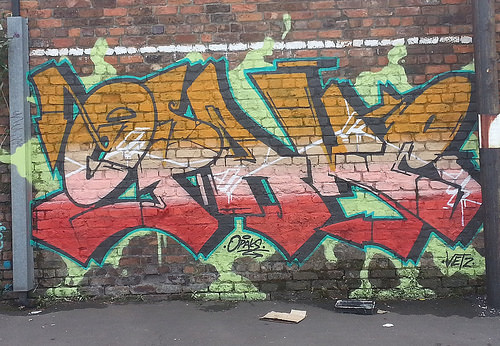<image>
Can you confirm if the graffiti is on the ground? No. The graffiti is not positioned on the ground. They may be near each other, but the graffiti is not supported by or resting on top of the ground. 